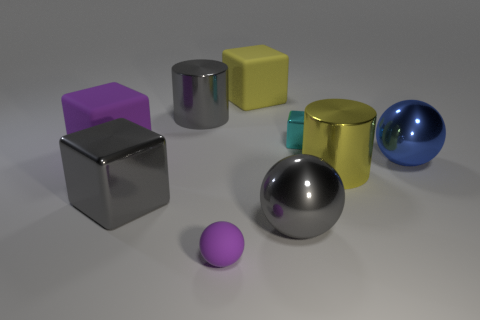Subtract all purple blocks. How many blocks are left? 3 Add 1 green balls. How many objects exist? 10 Subtract all gray balls. How many balls are left? 2 Subtract all yellow cylinders. How many gray blocks are left? 1 Subtract all green rubber cylinders. Subtract all metal objects. How many objects are left? 3 Add 7 purple spheres. How many purple spheres are left? 8 Add 6 tiny cyan cubes. How many tiny cyan cubes exist? 7 Subtract 1 cyan blocks. How many objects are left? 8 Subtract all blocks. How many objects are left? 5 Subtract 1 cylinders. How many cylinders are left? 1 